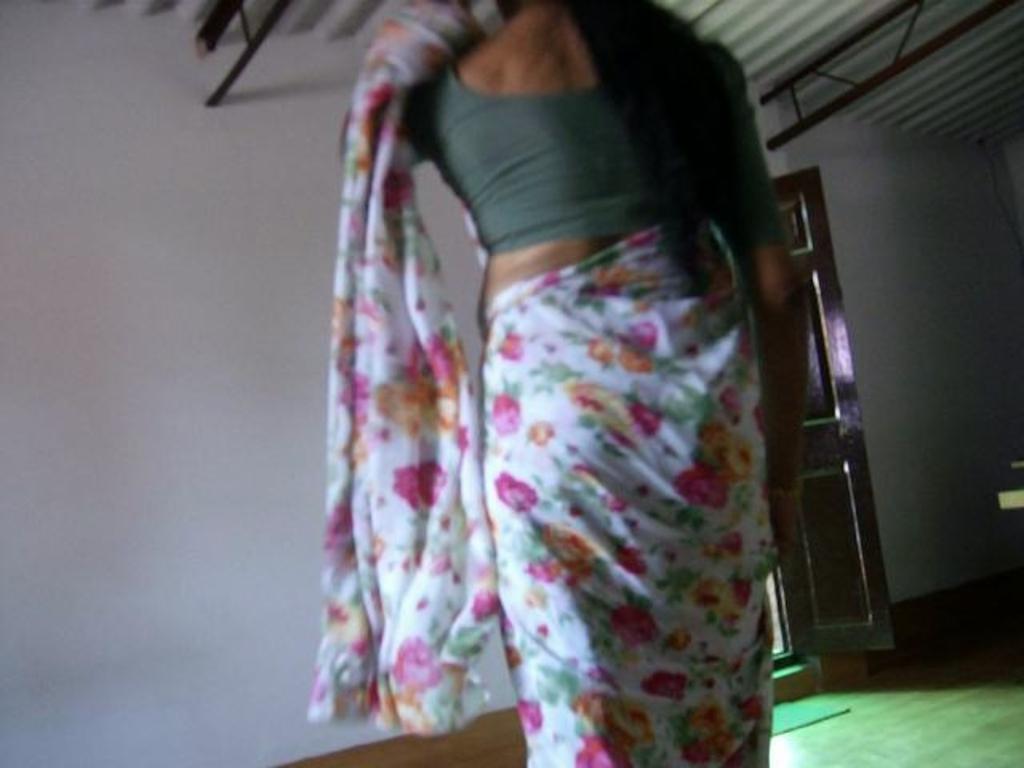Can you describe this image briefly? In this image we can see a woman. In the background we can see wall, door, mat on the floor and at the top we can see rods and roof. 